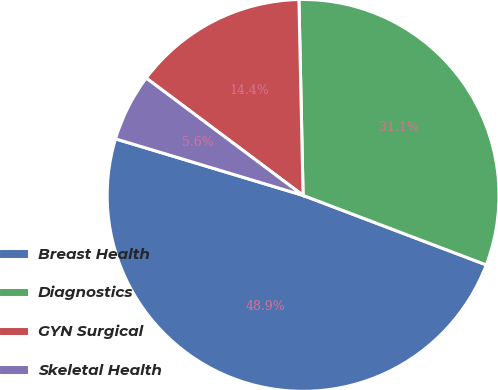Convert chart to OTSL. <chart><loc_0><loc_0><loc_500><loc_500><pie_chart><fcel>Breast Health<fcel>Diagnostics<fcel>GYN Surgical<fcel>Skeletal Health<nl><fcel>48.89%<fcel>31.11%<fcel>14.44%<fcel>5.56%<nl></chart> 